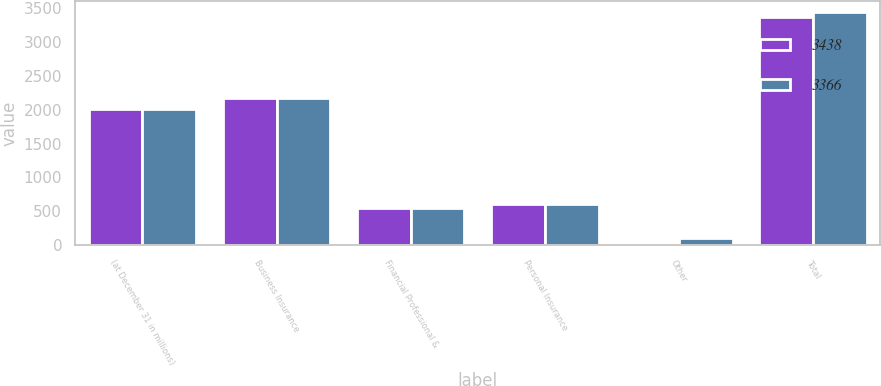Convert chart to OTSL. <chart><loc_0><loc_0><loc_500><loc_500><stacked_bar_chart><ecel><fcel>(at December 31 in millions)<fcel>Business Insurance<fcel>Financial Professional &<fcel>Personal Insurance<fcel>Other<fcel>Total<nl><fcel>3438<fcel>2007<fcel>2168<fcel>555<fcel>613<fcel>30<fcel>3366<nl><fcel>3366<fcel>2006<fcel>2168<fcel>551<fcel>613<fcel>106<fcel>3438<nl></chart> 